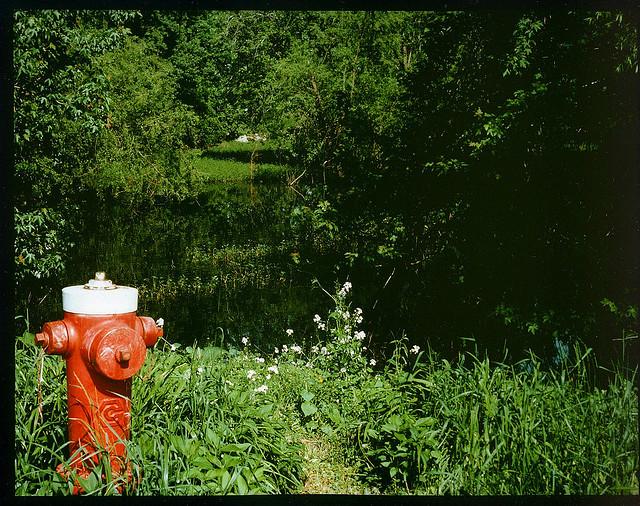What's the green stuff growing on the tree trunk?
Give a very brief answer. Grass. What is covering the floor?
Keep it brief. Grass. Is the red fire hydrant elevated off of the ground?
Answer briefly. No. Are all the flowers in the photo yellow?
Concise answer only. No. Is there a lake here?
Keep it brief. Yes. Does the plant on the right require much water?
Be succinct. No. What type of purple flower is next to the hydrant?
Be succinct. Daisy. What is wrong with the hydrant?
Answer briefly. Top missing. What color are the flowers?
Answer briefly. White. Have the flowers bloomed?
Keep it brief. Yes. What letters are on the hydrant?
Short answer required. C. Has the fire hydrant been freshly painted?
Quick response, please. Yes. The tree behind the fire hydrant has what kind of effect over it?
Keep it brief. Shadow. Is the fire hydrant located in the middle of the cement block?
Concise answer only. No. Is this the usual color of a fire hydrant?
Short answer required. Yes. What is the red thing?
Short answer required. Fire hydrant. Is this a residential area?
Give a very brief answer. No. How many different types of leaves are in the picture?
Keep it brief. Many. What's holding back the vegetation in the background?
Keep it brief. Pond. How many plugs does the hydrant have?
Answer briefly. 3. Where is the hydrant?
Quick response, please. In grass. Does that look like an airplane?
Short answer required. No. What is the item on the left normally used for?
Quick response, please. Fires. Does the red item have wheels?
Be succinct. No. Are there numbers on the fire hydrant?
Be succinct. No. Which presidential last name is on the fire hydrant?
Answer briefly. None. What season is this?
Concise answer only. Summer. What type of trees do you see?
Answer briefly. Oak. What is the large structure behind the fire hydrant used for?
Short answer required. Swimming. Is the bird sitting on a tree?
Concise answer only. No. What other colors are there?
Write a very short answer. Red. Is the hydrant old or new?
Write a very short answer. Old. What kind of plants can you spot?
Keep it brief. Weeds. Was this photo taken in the city?
Write a very short answer. No. What is the color of fire hydrant?
Short answer required. Red. What sort of plant is growing around the fire hydrant?
Keep it brief. Weeds. What else is in the picture besides the hydrant?
Answer briefly. Grass. What color is the hydrant?
Short answer required. Red. Is it raining?
Give a very brief answer. No. Is there a house?
Short answer required. No. What color is the fire hydrant?
Write a very short answer. Red. What number is on the fire hydrant?
Write a very short answer. 0. Is there a boat in the water?
Answer briefly. No. Is this an outdoor eating area?
Keep it brief. No. Is the fire hydrant red and blue?
Give a very brief answer. No. 